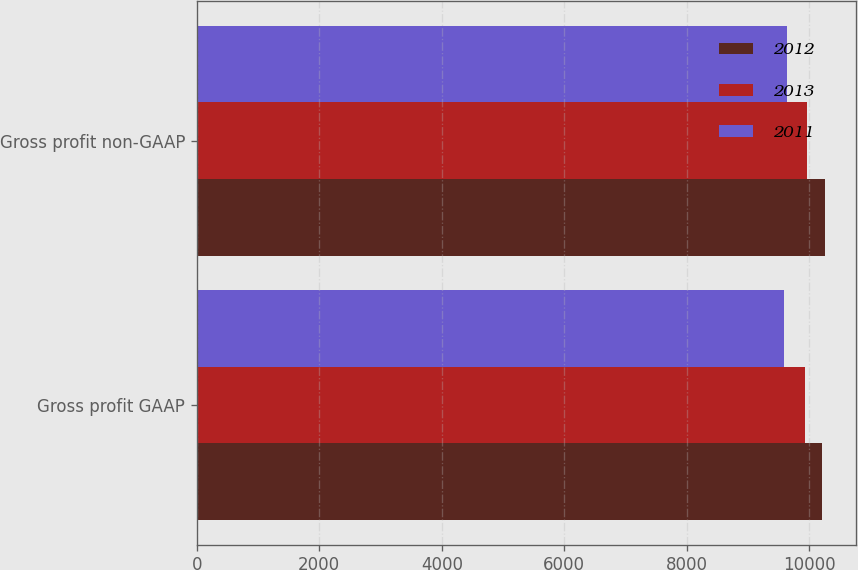Convert chart to OTSL. <chart><loc_0><loc_0><loc_500><loc_500><stacked_bar_chart><ecel><fcel>Gross profit GAAP<fcel>Gross profit non-GAAP<nl><fcel>2012<fcel>10201<fcel>10248<nl><fcel>2013<fcel>9932<fcel>9963<nl><fcel>2011<fcel>9590<fcel>9634<nl></chart> 